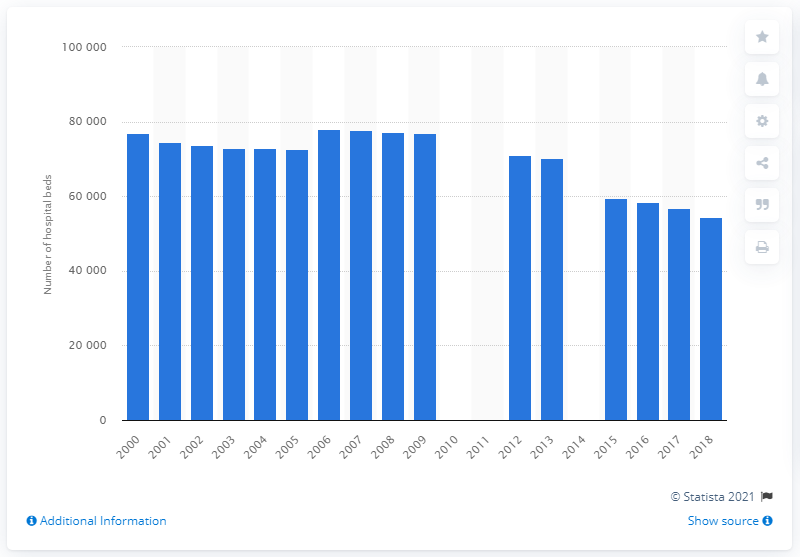List a handful of essential elements in this visual. Since the year 2000, the number of hospital beds in the Netherlands has declined. In 2006, the number of hospital beds in the Netherlands reached a record high of 77,680. There were 54,547 hospital beds in the Netherlands in 2018. 